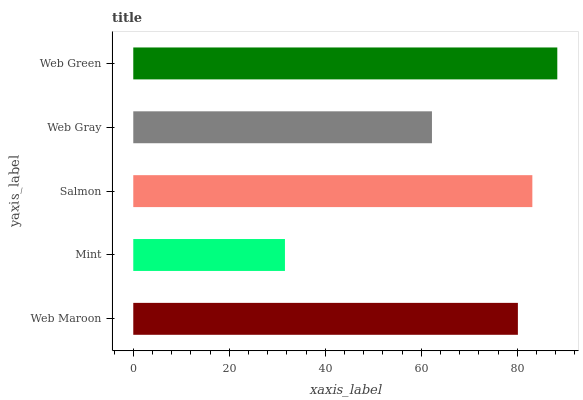Is Mint the minimum?
Answer yes or no. Yes. Is Web Green the maximum?
Answer yes or no. Yes. Is Salmon the minimum?
Answer yes or no. No. Is Salmon the maximum?
Answer yes or no. No. Is Salmon greater than Mint?
Answer yes or no. Yes. Is Mint less than Salmon?
Answer yes or no. Yes. Is Mint greater than Salmon?
Answer yes or no. No. Is Salmon less than Mint?
Answer yes or no. No. Is Web Maroon the high median?
Answer yes or no. Yes. Is Web Maroon the low median?
Answer yes or no. Yes. Is Mint the high median?
Answer yes or no. No. Is Salmon the low median?
Answer yes or no. No. 